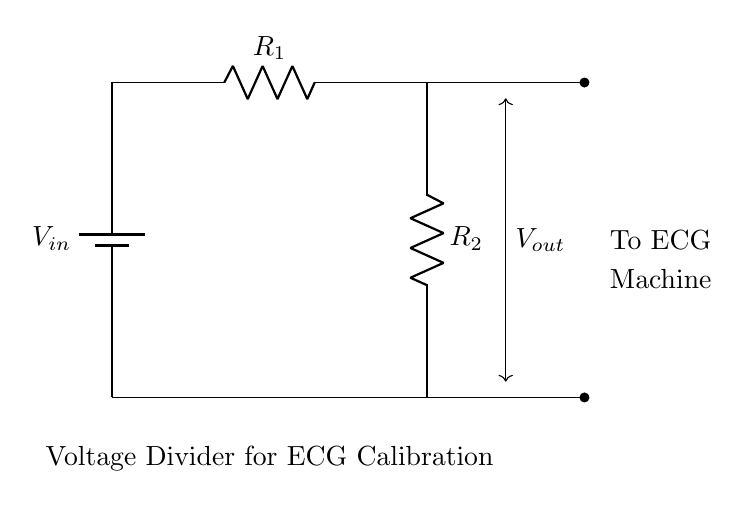What is the input voltage of the circuit? The input voltage, V_in, is represented by the battery1 component in the circuit diagram. The exact value is not specified in the diagram.
Answer: V_in What are the resistances used in the voltage divider? The resistances used in the voltage divider are labeled as R1 and R2 in the circuit diagram. They are connected in series to form the voltage divider configuration.
Answer: R1 and R2 What is the output voltage dependency in this circuit? The output voltage, V_out, depends on the values of R1 and R2 as well as the input voltage, V_in. According to the voltage divider rule, V_out can be calculated as V_out = (R2 / (R1 + R2)) * V_in.
Answer: V_out = (R2 / (R1 + R2)) * V_in Where does the output voltage connect? The output voltage connects to the ECG machine, as indicated by the label "To ECG Machine" next to the corresponding wire coming from the bottom of R2.
Answer: ECG Machine What type of circuit is this? This is a voltage divider circuit, as indicated by the arrangement of resistors, which divides the input voltage into a lower output voltage based on the resistor values.
Answer: Voltage Divider 